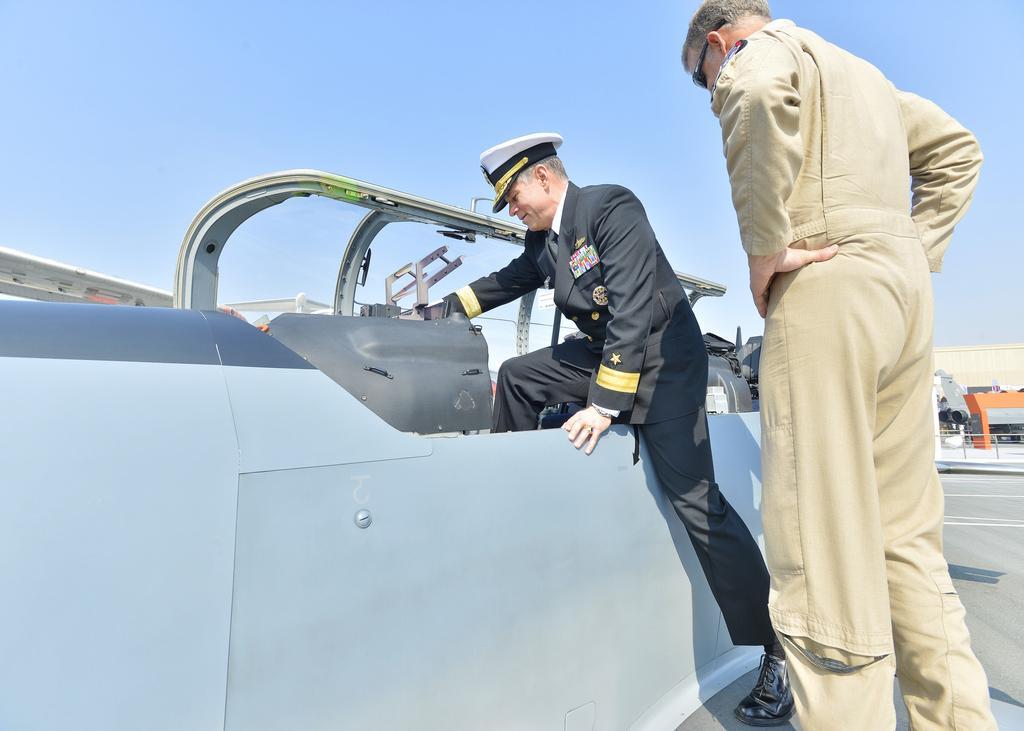Please provide a concise description of this image. Here is the man standing and the other man is getting into a vehicle. This is a glass door. In the background, that looks like a building. Here is the sky. 